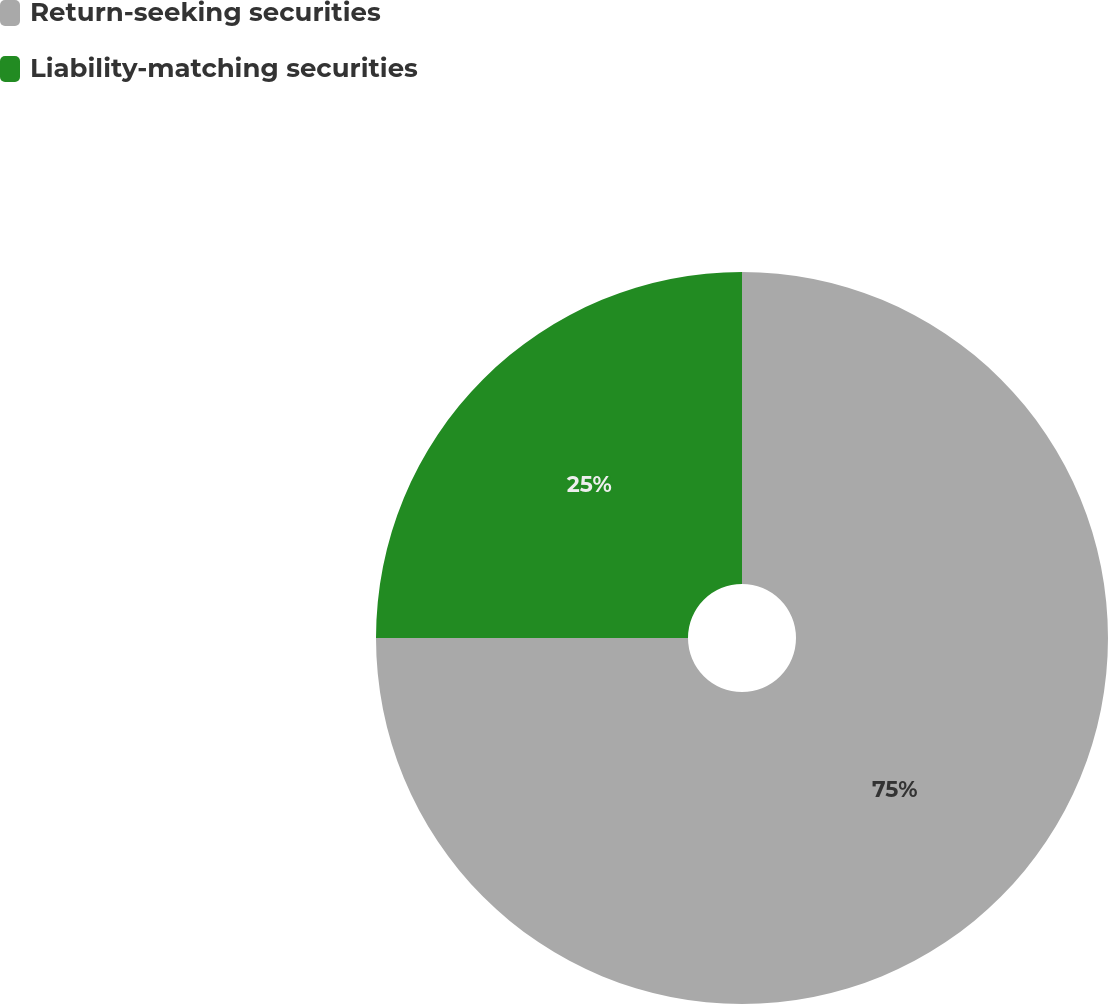<chart> <loc_0><loc_0><loc_500><loc_500><pie_chart><fcel>Return-seeking securities<fcel>Liability-matching securities<nl><fcel>75.0%<fcel>25.0%<nl></chart> 